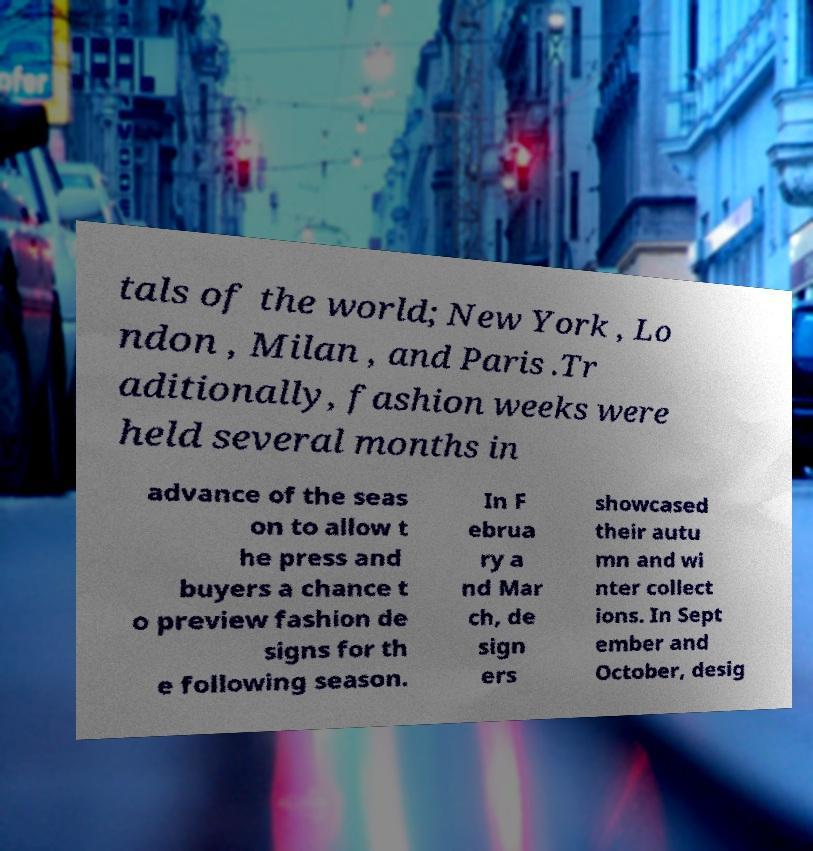Could you extract and type out the text from this image? tals of the world; New York , Lo ndon , Milan , and Paris .Tr aditionally, fashion weeks were held several months in advance of the seas on to allow t he press and buyers a chance t o preview fashion de signs for th e following season. In F ebrua ry a nd Mar ch, de sign ers showcased their autu mn and wi nter collect ions. In Sept ember and October, desig 